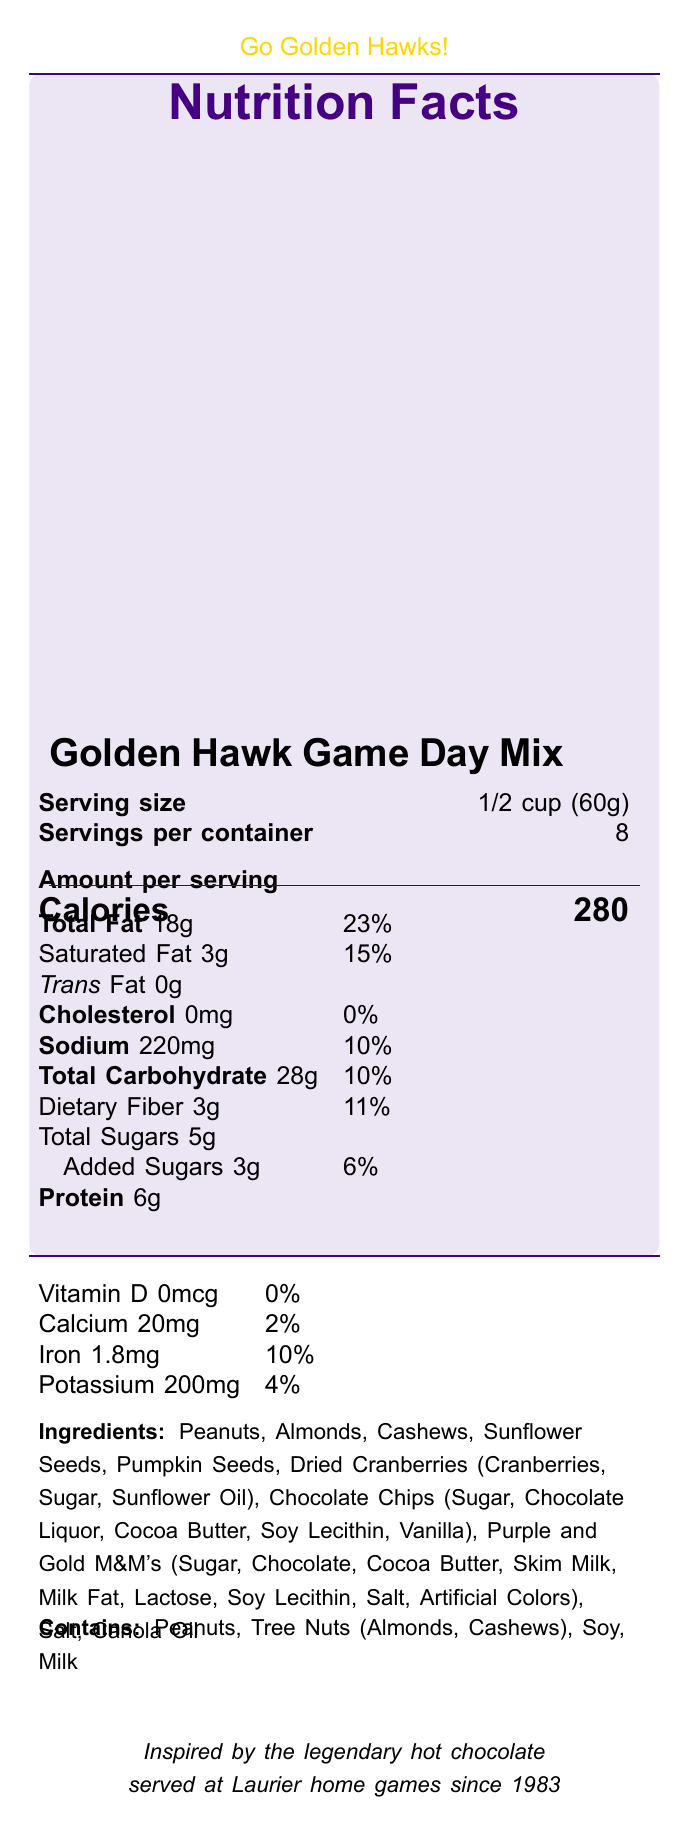what is the serving size of the Golden Hawk Game Day Mix? The document states that the serving size is 1/2 cup, which is equivalent to 60 grams.
Answer: 1/2 cup (60g) how many calories are there per serving? The document specifies that there are 280 calories per serving.
Answer: 280 what is the total fat content per serving? The document lists the total fat content as 18 grams per serving.
Answer: 18g how much sodium is in each serving? The nutrition facts indicate that each serving contains 220 milligrams of sodium.
Answer: 220mg what notable achievement is listed for the Wilfrid Laurier Golden Hawk sports team? Under "wilfrid_laurier_facts", the document mentions that the notable achievement is being the 2005 Vanier Cup Champions.
Answer: 2005 Vanier Cup Champions how many servings are in the entire container? The document states that there are 8 servings per container.
Answer: 8 which nutrient has the highest daily value percentage? The highest daily value percentage listed is for Total Fat, which is 23%.
Answer: Total Fat at 23% how much dietary fiber is in the Golden Hawk Game Day Mix? The document states that there are 3 grams of dietary fiber per serving.
Answer: 3g what allergens are present in this product? Under "allergen_info", the document specifies that the product contains peanuts, tree nuts (almonds, cashews), soy, and milk.
Answer: Peanuts, Tree Nuts (Almonds, Cashews), Soy, Milk Which of the following ingredients is NOT listed in the Golden Hawk Game Day Mix?
A. Peanuts
B. Chocolate Chips
C. Raisins
D. Sunflower Seeds The document lists all ingredients, and raisins are not included.
Answer: C. Raisins How much protein does each serving of the Golden Hawk Game Day Mix contain?
A. 4g
B. 5g
C. 6g
D. 7g The document states that each serving contains 6 grams of protein.
Answer: C. 6g what is the amount of vitamin D in the product? The nutrition facts section lists the amount of vitamin D as 0 micrograms.
Answer: 0mcg Does this product contain any trans fat? The document states that there are 0 grams of trans fat in this product.
Answer: No summarize the key nutritional information of the Golden Hawk Game Day Mix. This summary includes the most essential nutritional facts provided in the document.
Answer: The Golden Hawk Game Day Mix has a serving size of 1/2 cup (60g) and provides 280 calories per serving. It contains 18g of total fat (23% DV), 220mg of sodium (10% DV), 28g of total carbohydrates (10% DV) including 3g of dietary fiber (11% DV) and 5g of total sugars, with 3g of added sugars (6% DV). It also supplies 6g of protein, and small amounts of calcium, iron, and potassium. What was the inspiration behind the Golden Hawk Game Day Mix? The document mentions that the mix is inspired by the legendary hot chocolate served at Laurier home games since 1983.
Answer: Inspired by the legendary hot chocolate served at Laurier home games since 1983 what is the total carbohydrate amount per serving? The document indicates that there are 28 grams of total carbohydrates per serving.
Answer: 28g Who is a notable player mentioned in the document? Under "wilfrid_laurier_facts", Dillon Campbell, a football player, is noted.
Answer: Dillon Campbell (Football) Based on the document, how many team colors are there for Wilfrid Laurier Golden Hawks and what are they called? The document specifies that the team colors are purple and gold.
Answer: 2, Purple and Gold How many total sugars are in one serving of the Golden Hawk Game Day Mix? The document indicates that there are 5 grams of total sugars in one serving.
Answer: 5g What are the mascots of Wilfrid Laurier University? The document specifies that the mascot is the Golden Hawk.
Answer: Golden Hawk How many of the components listed are tree nuts? The document mentions that almonds and cashews are tree nuts contained in the mix.
Answer: 2 What is the vitamin D percentage daily value per serving? The document states that the percent daily value for Vitamin D is 0%.
Answer: 0% Does this product contain any significant source of calcium? The document lists calcium content as 2% of daily value, which is relatively low and not considered a significant source.
Answer: No What is the main idea of the document? This main idea encompasses the document's focus on the nutritional details of the snack mix along with related Wilfrid Laurier University sports team trivia.
Answer: The document provides detailed nutritional information about the Golden Hawk Game Day Mix, a snack sold at Wilfrid Laurier University sporting events, including serving size, calorie count, and allergen information, as well as fun facts related to Wilfrid Laurier University's sports teams. Who designed the packaging for the Golden Hawk Game Day Mix? The document does not include any information about the designer of the packaging.
Answer: I don't know 